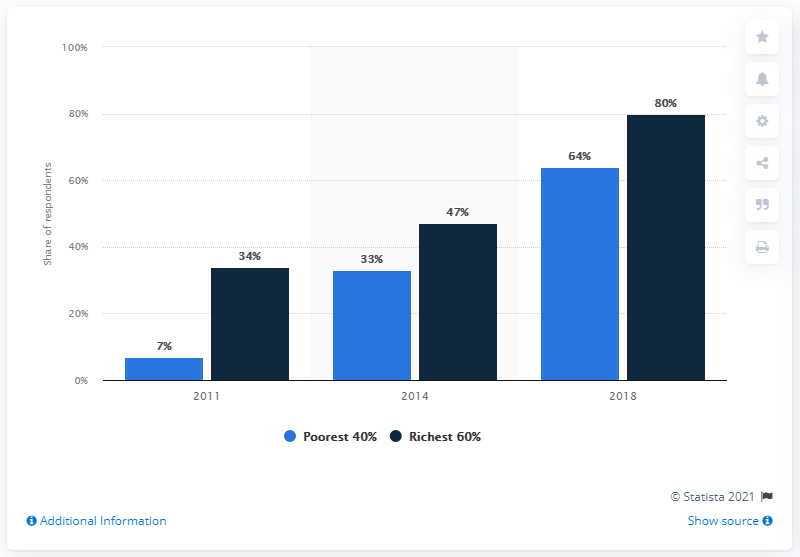Mention a couple of crucial points in this snapshot. What is the value of the middle blue bar in the range of 33 to 37? In 2011, the difference in ownership between the poorest 40% and the richest 60% was greater than in 2014. 